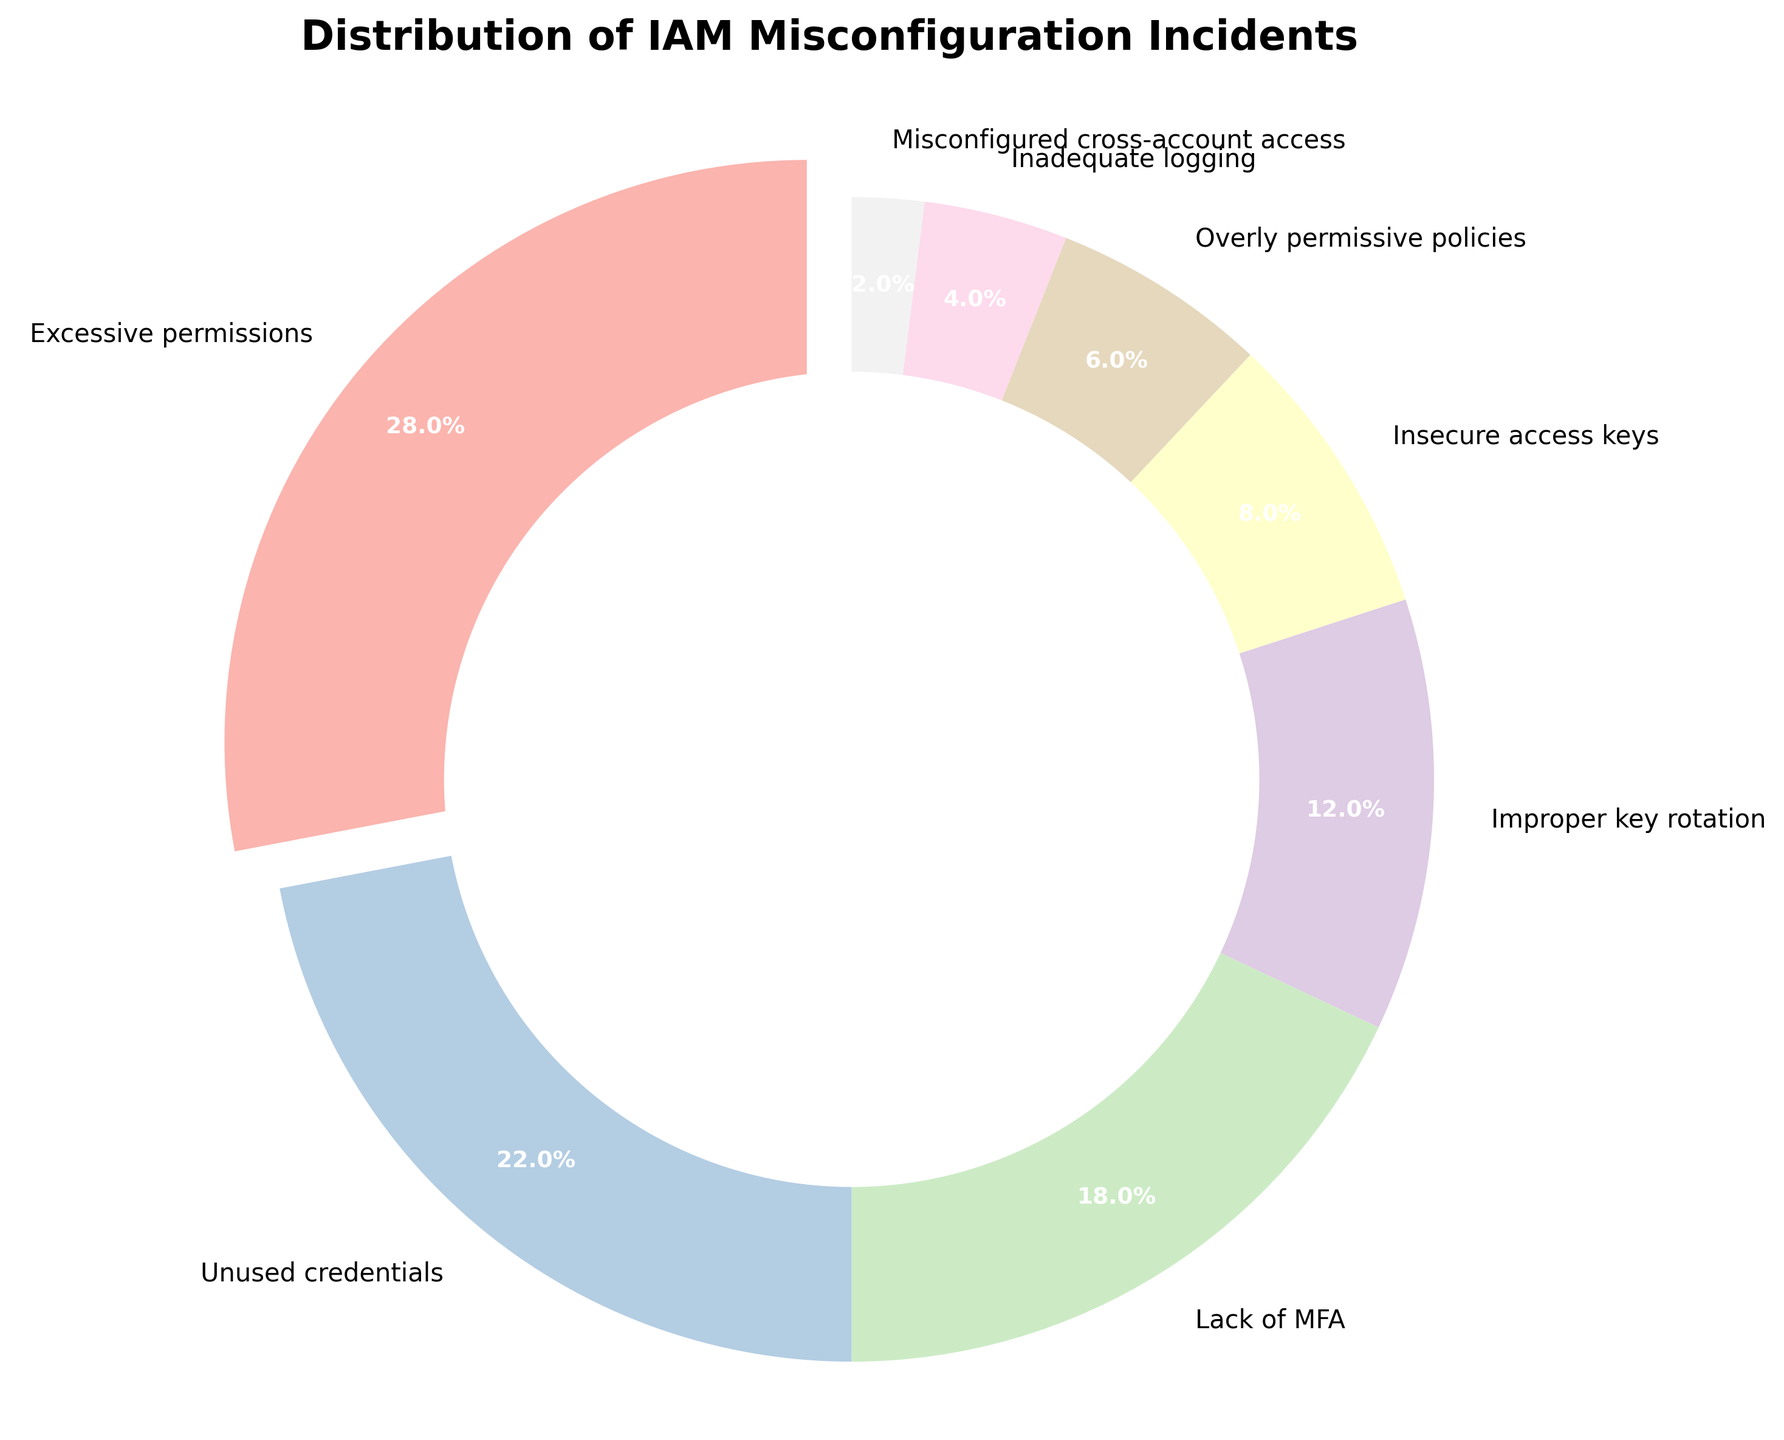Which category has the highest percentage of IAM misconfiguration incidents? First, identify which category from the plot has the largest share. The "Excessive permissions" category takes the largest segment and has the highest percentage at 28%.
Answer: Excessive permissions What is the percentage difference between "Unused credentials" and "Lack of MFA"? First, note the percentages of "Unused credentials" (22%) and "Lack of MFA" (18%). Subtract the percentage of "Lack of MFA" from "Unused credentials" (22% - 18%) to get the difference.
Answer: 4% Which category is represented by the smallest segment, and what is its percentage? Locate the smallest segment in the pie chart and refer to its label. The "Misconfigured cross-account access" category occupies the smallest segment at 2%.
Answer: Misconfigured cross-account access, 2% What percentage of incidents are caused by "Improper key rotation" and "Insecure access keys" combined? Identify the percentages for "Improper key rotation" (12%) and "Insecure access keys" (8%). Add these percentages together to find the combined value (12% + 8%).
Answer: 20% Is the percentage of "Overly permissive policies" higher or lower than that of "Inadequate logging"? Identify and compare the percentages for "Overly permissive policies" (6%) and "Inadequate logging" (4%). The "Overly permissive policies" percentage is higher than that of "Inadequate logging".
Answer: Higher How many categories have a percentage less than 10%? Evaluate each segment's percentage and count the numbers that are less than 10%. The categories are "Insecure access keys" (8%), "Overly permissive policies" (6%), "Inadequate logging" (4%), and "Misconfigured cross-account access" (2%). There are four such categories.
Answer: 4 If the total number of IAM misconfiguration incidents was 1000, how many incidents would be due to "Excessive permissions"? The "Excessive permissions" category represents 28%. Calculate 28% of 1000 by multiplying 1000 by 0.28 (1000 * 0.28).
Answer: 280 Which categories combined form more than 50% of the incidents? Evaluate the sum of percentages for categories until the total exceeds 50%. "Excessive permissions" (28%) and "Unused credentials" (22%) together make 50%. Including "Lack of MFA" (18%) brings the total to 68%. These three categories form more than 50% of the incidents.
Answer: Excessive permissions, Unused credentials, Lack of MFA 